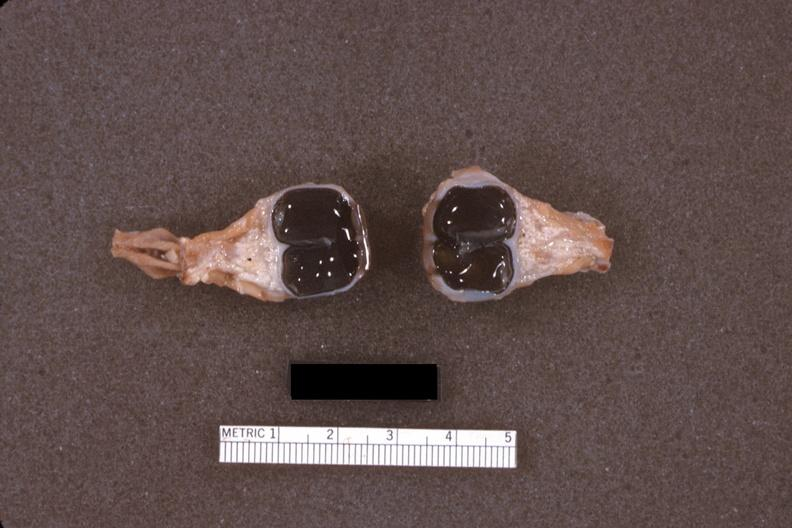s conjoined twins cephalothoracopagus janiceps present?
Answer the question using a single word or phrase. Yes 